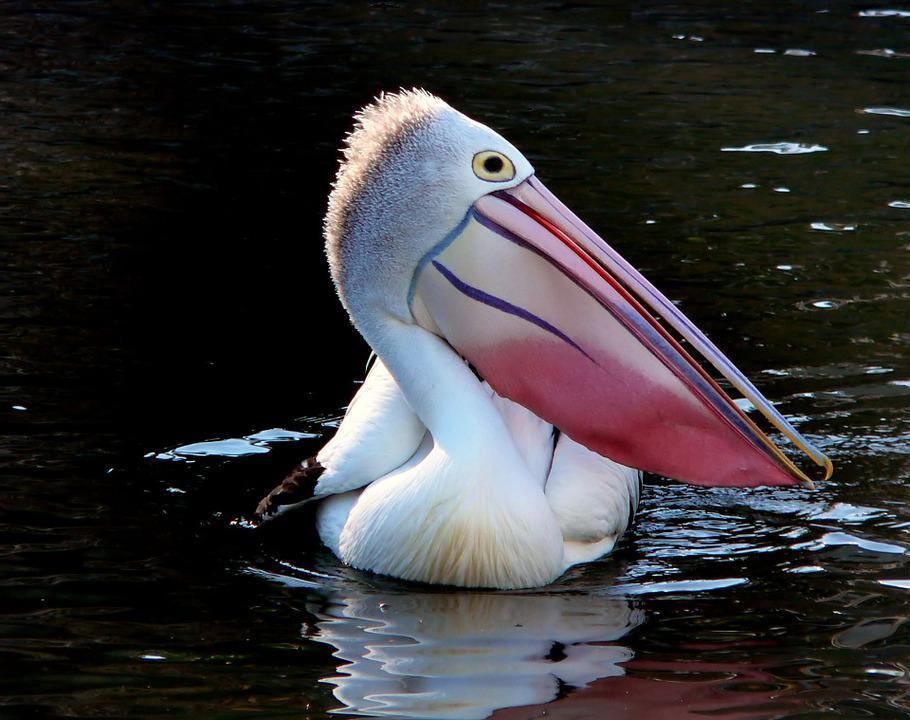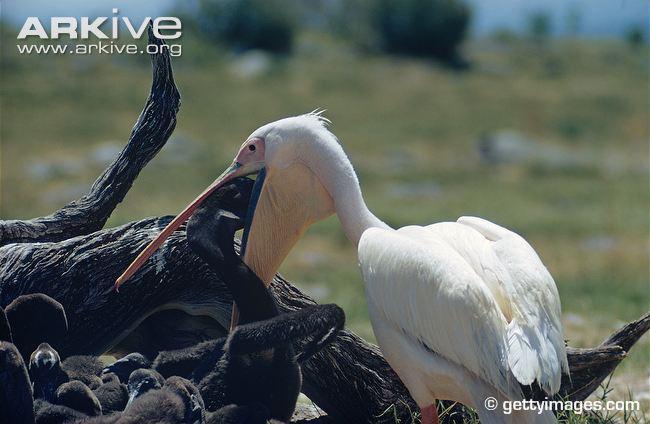The first image is the image on the left, the second image is the image on the right. Given the left and right images, does the statement "There is one bird flying in the picture on the right." hold true? Answer yes or no. No. 